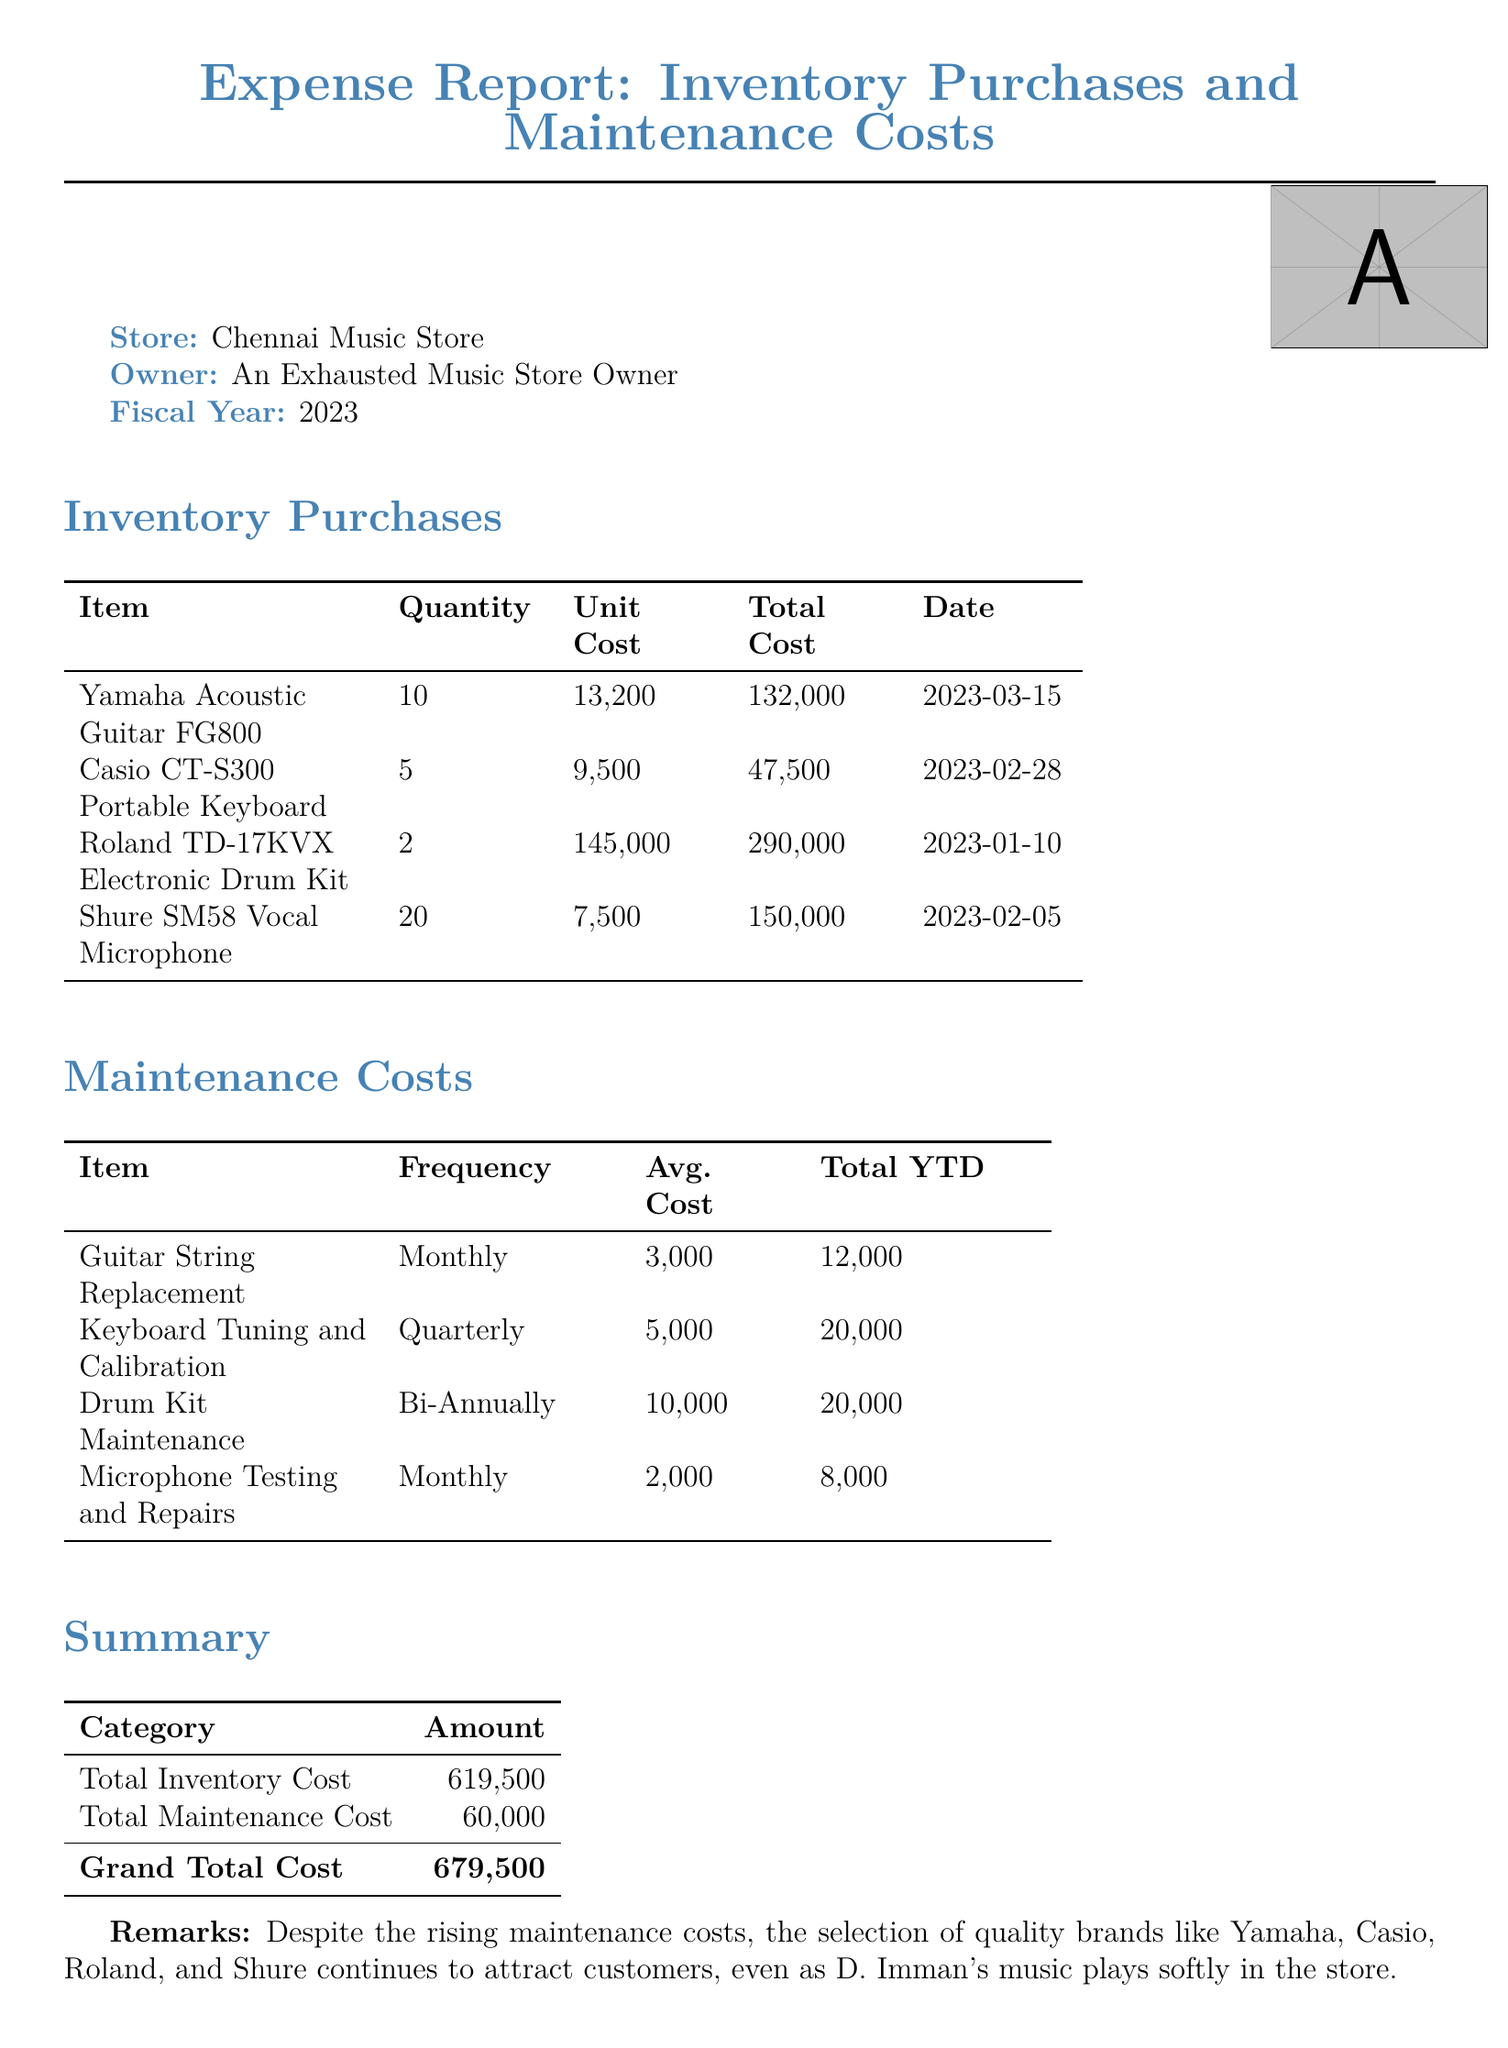What is the total inventory cost? The total inventory cost is listed in the summary section of the document.
Answer: ₹619,500 How many Yamaha Acoustic Guitars were purchased? The quantity of Yamaha Acoustic Guitars is specified in the inventory purchases table.
Answer: 10 What is the average cost for Keyboard Tuning and Calibration? The average cost for Keyboard Tuning and Calibration can be found under maintenance costs.
Answer: ₹5,000 When was the Casio CT-S300 Portable Keyboard purchased? The purchase date for the Casio CT-S300 Portable Keyboard is provided in the inventory purchases table.
Answer: 2023-02-28 What is the total maintenance cost? The total maintenance cost is summarized in the general overview of the document.
Answer: ₹60,000 What type of microphone is listed in the inventory? The type of microphone mentioned can be found in the inventory purchases section.
Answer: Shure SM58 Vocal Microphone How often is Guitar String Replacement needed? The frequency of Guitar String Replacement is indicated in the maintenance costs table.
Answer: Monthly What is the grand total cost? The grand total cost is calculated and presented in the summary section of the report.
Answer: ₹679,500 What are the total costs for Drum Kit Maintenance? The total costs for Drum Kit Maintenance are detailed in the maintenance cost table.
Answer: ₹20,000 